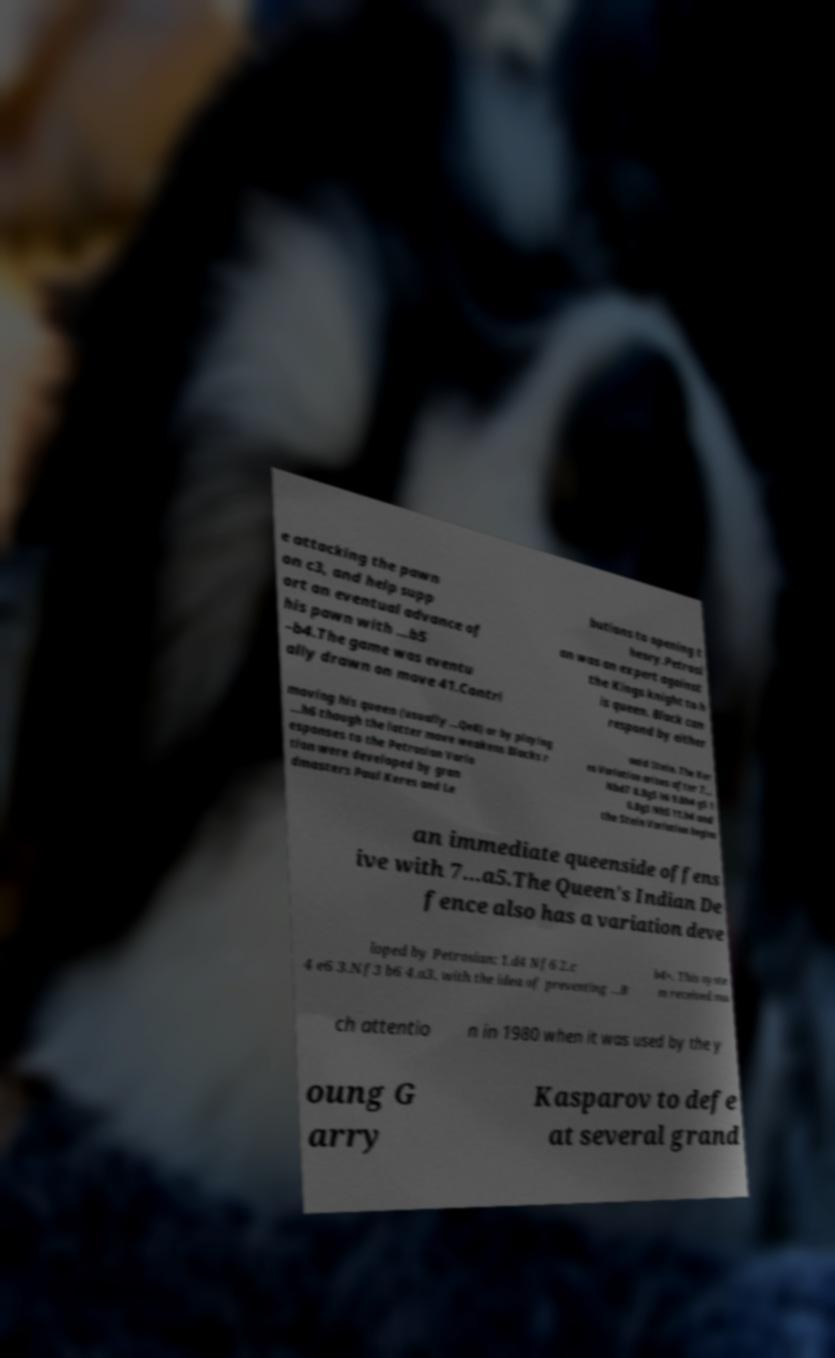There's text embedded in this image that I need extracted. Can you transcribe it verbatim? e attacking the pawn on c3, and help supp ort an eventual advance of his pawn with ...b5 –b4.The game was eventu ally drawn on move 41.Contri butions to opening t heory.Petrosi an was an expert against the Kings knight to h is queen. Black can respond by either moving his queen (usually ...Qe8) or by playing ...h6 though the latter move weakens Blacks r esponses to the Petrosian Varia tion were developed by gran dmasters Paul Keres and Le onid Stein. The Ker es Variation arises after 7... Nbd7 8.Bg5 h6 9.Bh4 g5 1 0.Bg3 Nh5 11.h4 and the Stein Variation begins an immediate queenside offens ive with 7...a5.The Queen's Indian De fence also has a variation deve loped by Petrosian: 1.d4 Nf6 2.c 4 e6 3.Nf3 b6 4.a3, with the idea of preventing ...B b4+. This syste m received mu ch attentio n in 1980 when it was used by the y oung G arry Kasparov to defe at several grand 